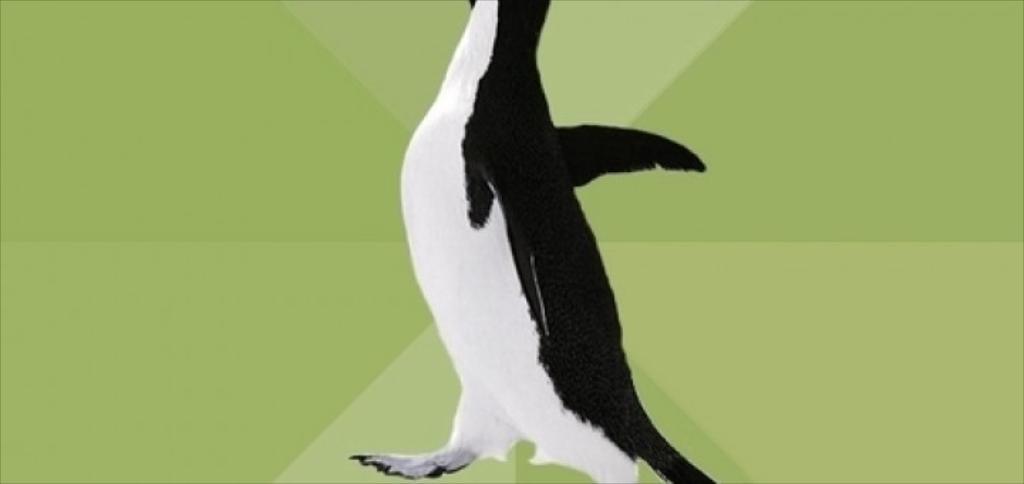Describe this image in one or two sentences. This is a painting. In this image we can see painting of penguin. 